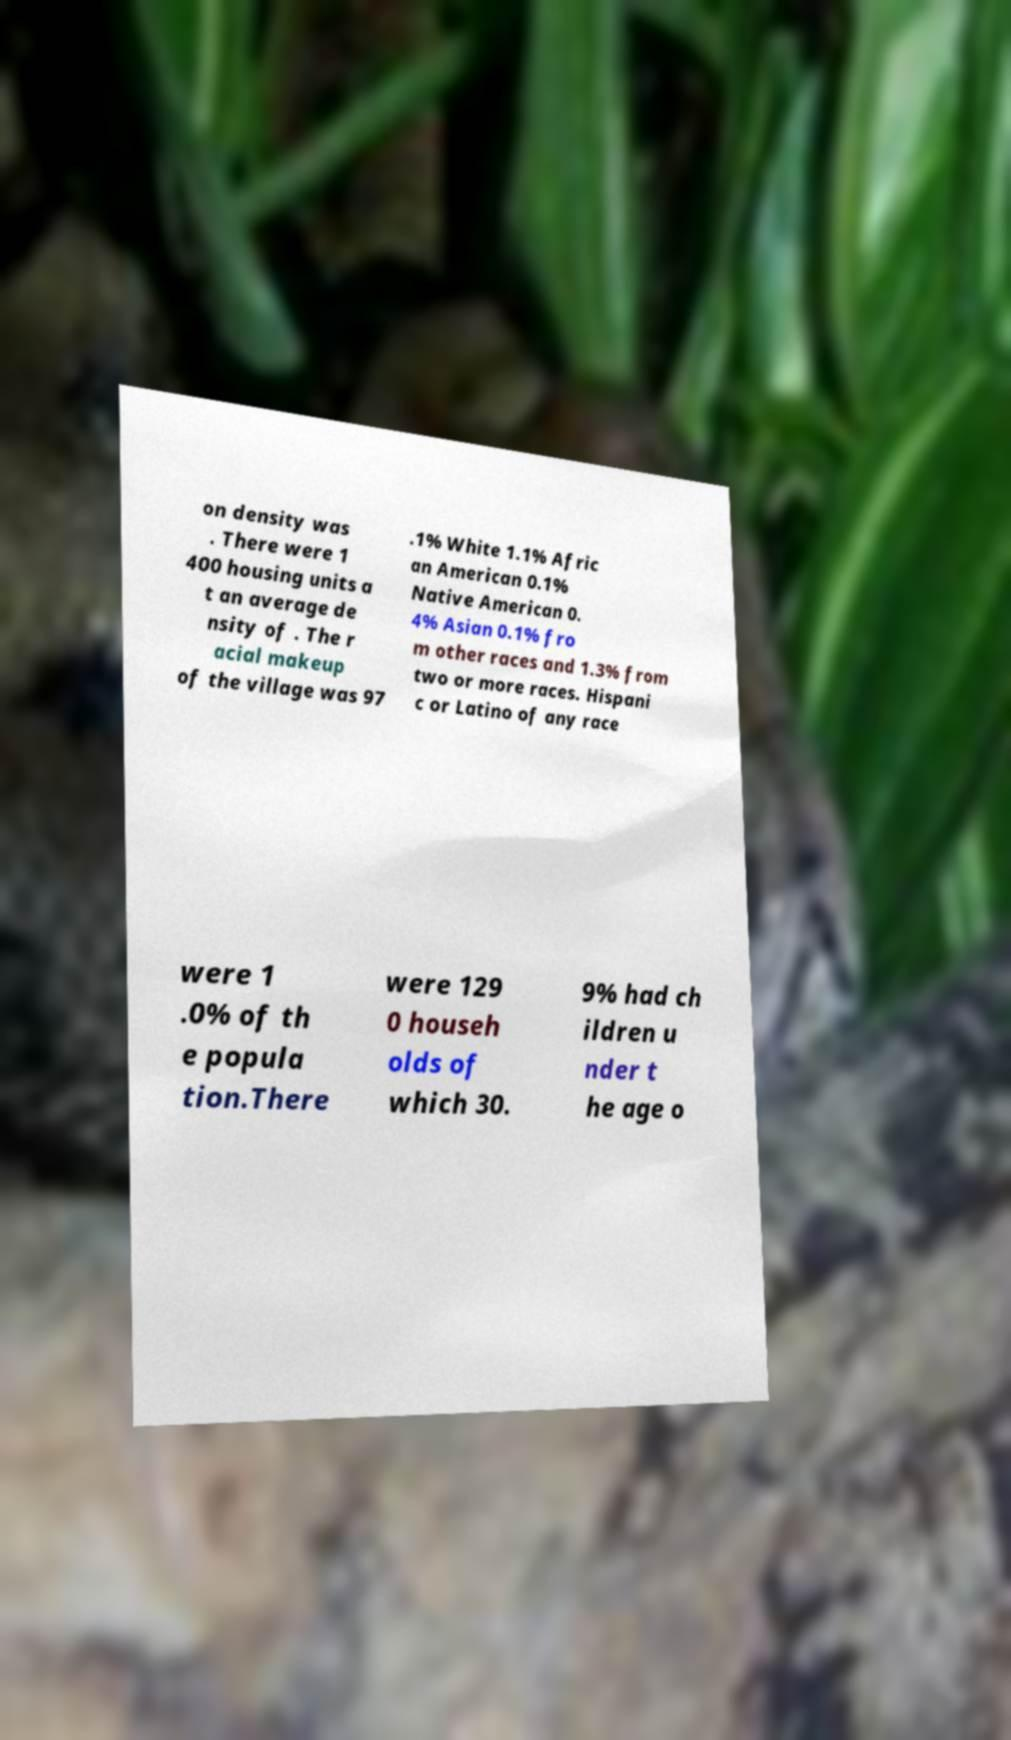Can you accurately transcribe the text from the provided image for me? on density was . There were 1 400 housing units a t an average de nsity of . The r acial makeup of the village was 97 .1% White 1.1% Afric an American 0.1% Native American 0. 4% Asian 0.1% fro m other races and 1.3% from two or more races. Hispani c or Latino of any race were 1 .0% of th e popula tion.There were 129 0 househ olds of which 30. 9% had ch ildren u nder t he age o 